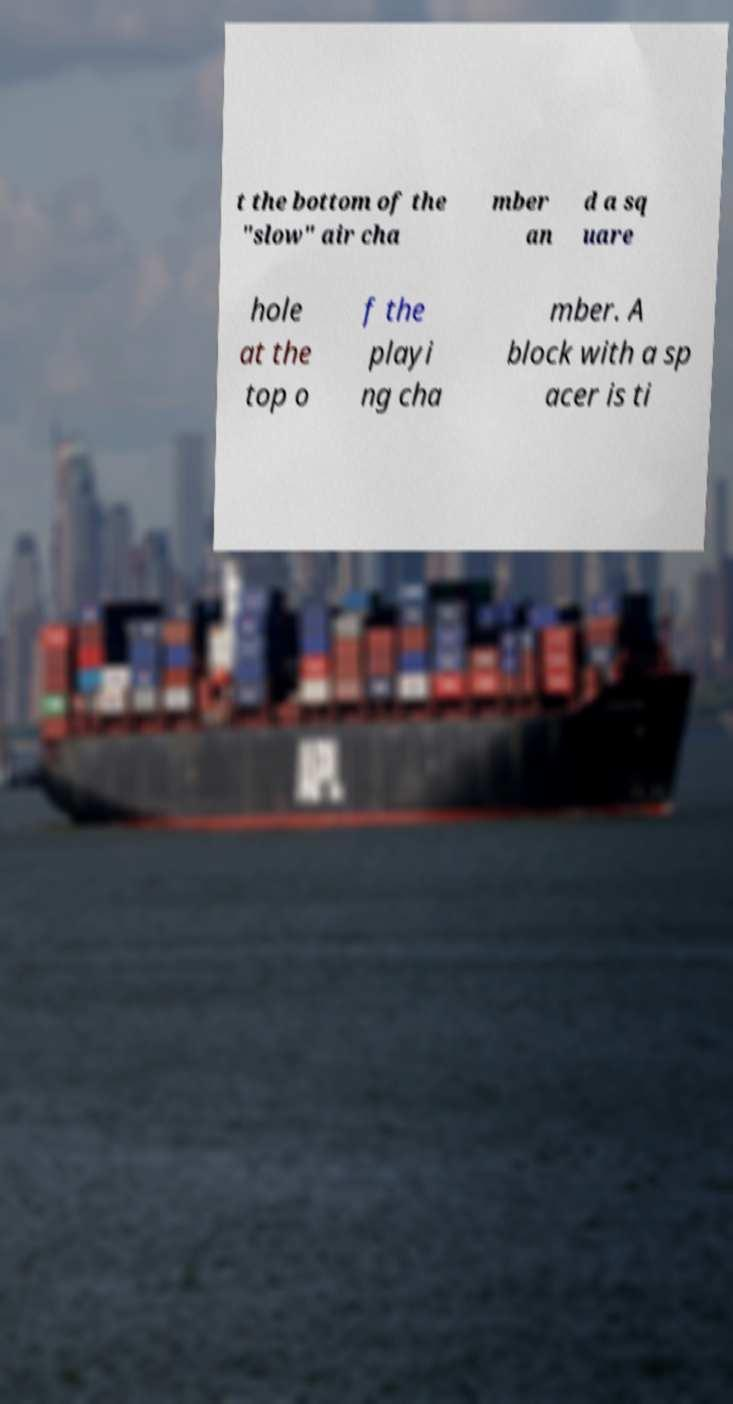For documentation purposes, I need the text within this image transcribed. Could you provide that? t the bottom of the "slow" air cha mber an d a sq uare hole at the top o f the playi ng cha mber. A block with a sp acer is ti 